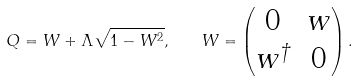<formula> <loc_0><loc_0><loc_500><loc_500>Q = W + \Lambda \sqrt { 1 - W ^ { 2 } } , \quad W = \begin{pmatrix} 0 & w \\ w ^ { \dag } & 0 \end{pmatrix} .</formula> 